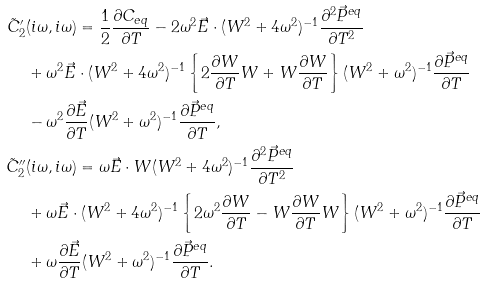Convert formula to latex. <formula><loc_0><loc_0><loc_500><loc_500>\tilde { C } ^ { \prime } _ { 2 } & ( i \omega , i \omega ) = \frac { 1 } { 2 } \frac { \partial C _ { e q } } { \partial T } - 2 \omega ^ { 2 } \vec { E } \cdot ( W ^ { 2 } + 4 \omega ^ { 2 } ) ^ { - 1 } \frac { \partial ^ { 2 } \vec { P } ^ { e q } } { \partial T ^ { 2 } } \\ & + \omega ^ { 2 } \vec { E } \cdot ( W ^ { 2 } + 4 \omega ^ { 2 } ) ^ { - 1 } \left \{ 2 \frac { \partial W } { \partial T } W + W \frac { \partial W } { \partial T } \right \} ( W ^ { 2 } + \omega ^ { 2 } ) ^ { - 1 } \frac { \partial \vec { P } ^ { e q } } { \partial T } \\ & - \omega ^ { 2 } \frac { \partial \vec { E } } { \partial T } ( W ^ { 2 } + \omega ^ { 2 } ) ^ { - 1 } \frac { \partial \vec { P } ^ { e q } } { \partial T } , \\ \tilde { C } ^ { \prime \prime } _ { 2 } & ( i \omega , i \omega ) = \omega \vec { E } \cdot W ( W ^ { 2 } + 4 \omega ^ { 2 } ) ^ { - 1 } \frac { \partial ^ { 2 } \vec { P } ^ { e q } } { \partial T ^ { 2 } } \\ & + \omega \vec { E } \cdot ( W ^ { 2 } + 4 \omega ^ { 2 } ) ^ { - 1 } \left \{ 2 \omega ^ { 2 } \frac { \partial W } { \partial T } - W \frac { \partial W } { \partial T } W \right \} ( W ^ { 2 } + \omega ^ { 2 } ) ^ { - 1 } \frac { \partial \vec { P } ^ { e q } } { \partial T } \\ & + \omega \frac { \partial \vec { E } } { \partial T } ( W ^ { 2 } + \omega ^ { 2 } ) ^ { - 1 } \frac { \partial \vec { P } ^ { e q } } { \partial T } .</formula> 